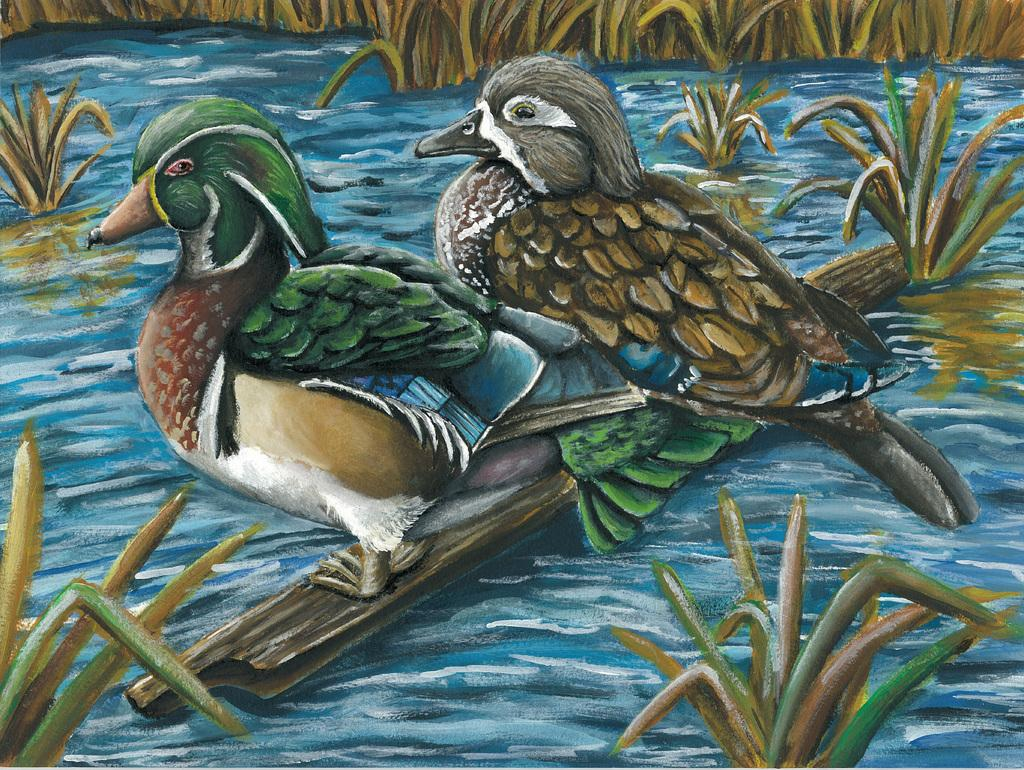What type of image is being described? The image is a cartoon. How many birds are present in the image? There are two birds in the image. What are the birds standing on? The birds are standing on a stick. What is the stick doing in the image? The stick is sailing on a river. What can be seen in the background of the image? There are plants in the background of the image. What type of trousers is the beggar wearing in the image? There is no beggar present in the image, and therefore no trousers to describe. How many bananas can be seen in the image? There are no bananas visible in the image. 